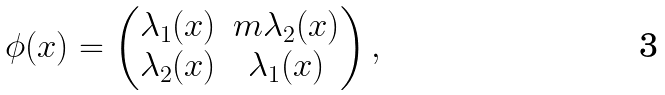Convert formula to latex. <formula><loc_0><loc_0><loc_500><loc_500>\phi ( x ) = \begin{pmatrix} \lambda _ { 1 } ( x ) & m \lambda _ { 2 } ( x ) \\ \lambda _ { 2 } ( x ) & \lambda _ { 1 } ( x ) \end{pmatrix} ,</formula> 